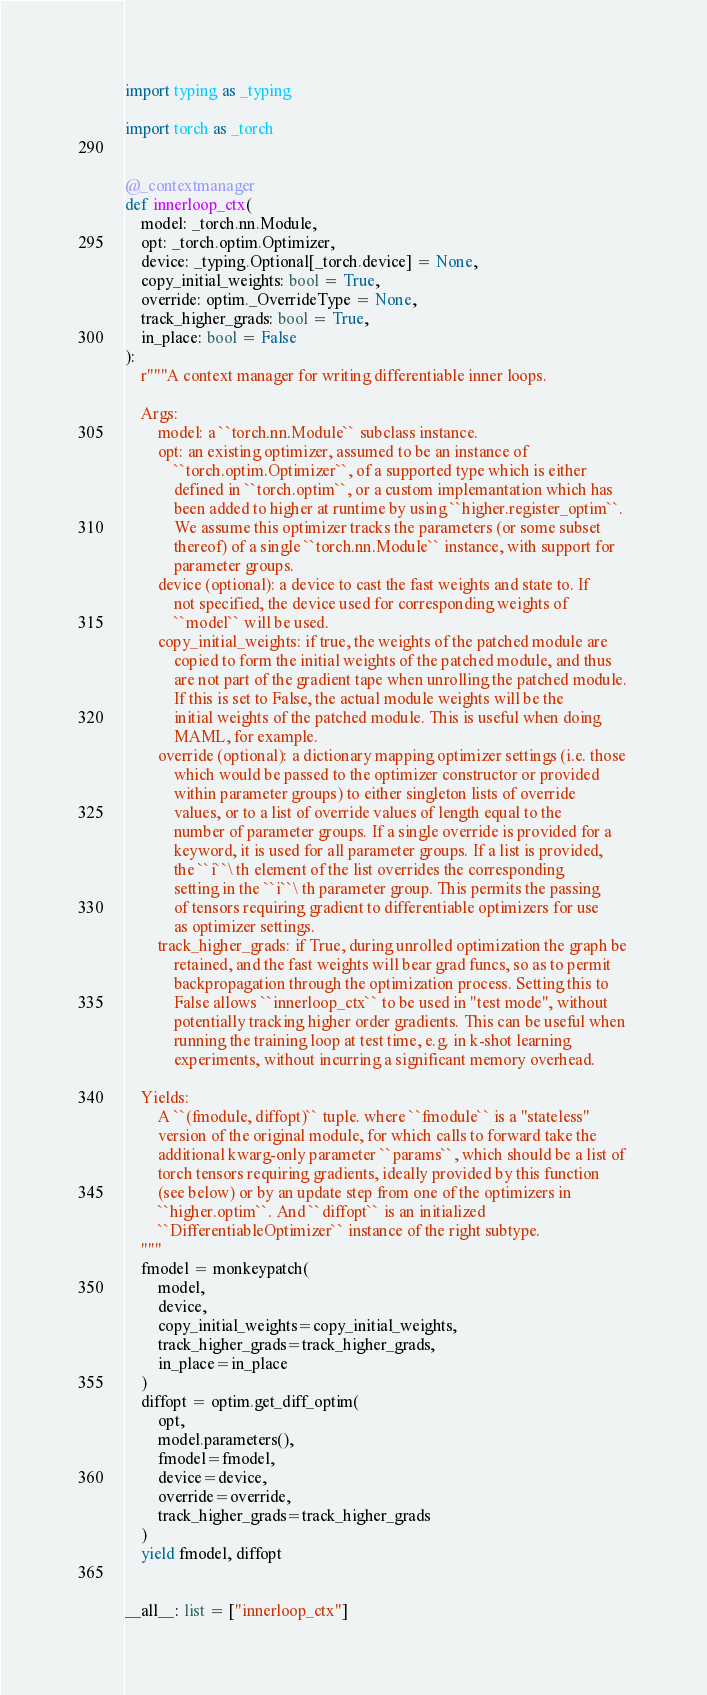Convert code to text. <code><loc_0><loc_0><loc_500><loc_500><_Python_>import typing as _typing

import torch as _torch


@_contextmanager
def innerloop_ctx(
    model: _torch.nn.Module,
    opt: _torch.optim.Optimizer,
    device: _typing.Optional[_torch.device] = None,
    copy_initial_weights: bool = True,
    override: optim._OverrideType = None,
    track_higher_grads: bool = True,
    in_place: bool = False
):
    r"""A context manager for writing differentiable inner loops.

    Args:
        model: a ``torch.nn.Module`` subclass instance.
        opt: an existing optimizer, assumed to be an instance of
            ``torch.optim.Optimizer``, of a supported type which is either 
            defined in ``torch.optim``, or a custom implemantation which has 
            been added to higher at runtime by using ``higher.register_optim``. 
            We assume this optimizer tracks the parameters (or some subset 
            thereof) of a single ``torch.nn.Module`` instance, with support for 
            parameter groups.
        device (optional): a device to cast the fast weights and state to. If
            not specified, the device used for corresponding weights of 
            ``model`` will be used.
        copy_initial_weights: if true, the weights of the patched module are
            copied to form the initial weights of the patched module, and thus
            are not part of the gradient tape when unrolling the patched module.
            If this is set to False, the actual module weights will be the
            initial weights of the patched module. This is useful when doing
            MAML, for example.
        override (optional): a dictionary mapping optimizer settings (i.e. those
            which would be passed to the optimizer constructor or provided
            within parameter groups) to either singleton lists of override
            values, or to a list of override values of length equal to the
            number of parameter groups. If a single override is provided for a
            keyword, it is used for all parameter groups. If a list is provided,
            the ``i``\ th element of the list overrides the corresponding 
            setting in the ``i``\ th parameter group. This permits the passing 
            of tensors requiring gradient to differentiable optimizers for use 
            as optimizer settings.
        track_higher_grads: if True, during unrolled optimization the graph be
            retained, and the fast weights will bear grad funcs, so as to permit
            backpropagation through the optimization process. Setting this to
            False allows ``innerloop_ctx`` to be used in "test mode", without
            potentially tracking higher order gradients. This can be useful when
            running the training loop at test time, e.g. in k-shot learning
            experiments, without incurring a significant memory overhead.

    Yields:
        A ``(fmodule, diffopt)`` tuple. where ``fmodule`` is a "stateless" 
        version of the original module, for which calls to forward take the 
        additional kwarg-only parameter ``params``, which should be a list of 
        torch tensors requiring gradients, ideally provided by this function 
        (see below) or by an update step from one of the optimizers in 
        ``higher.optim``. And ``diffopt`` is an initialized 
        ``DifferentiableOptimizer`` instance of the right subtype.
    """
    fmodel = monkeypatch(
        model,
        device,
        copy_initial_weights=copy_initial_weights,
        track_higher_grads=track_higher_grads,
        in_place=in_place
    )
    diffopt = optim.get_diff_optim(
        opt,
        model.parameters(),
        fmodel=fmodel,
        device=device,
        override=override,
        track_higher_grads=track_higher_grads
    )
    yield fmodel, diffopt


__all__: list = ["innerloop_ctx"]
</code> 